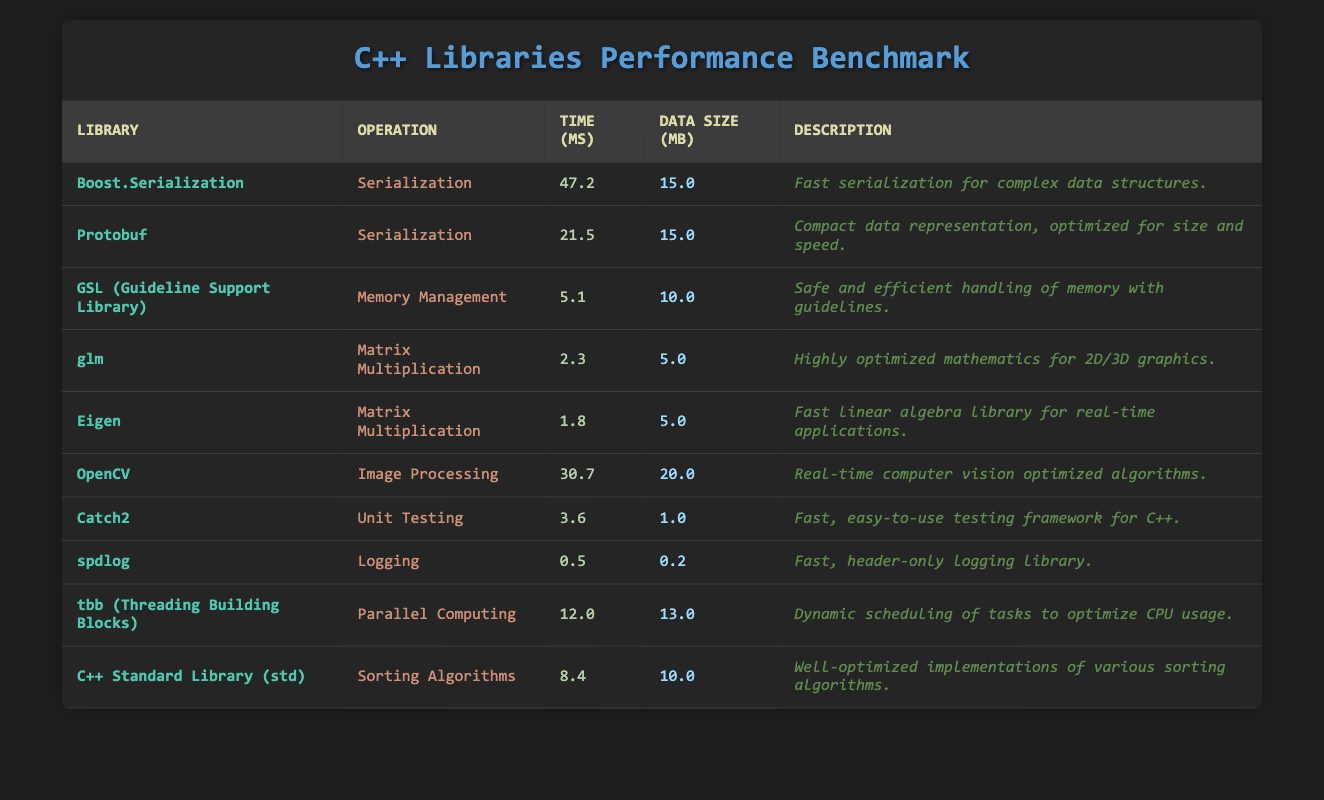What library took the longest time for serialization? The table shows that Boost.Serialization took the longest time for serialization at 47.2 ms, compared to Protobuf at 21.5 ms.
Answer: Boost.Serialization Which library is the fastest for matrix multiplication? According to the table, Eigen took 1.8 ms for matrix multiplication, making it the fastest compared to glm, which took 2.3 ms.
Answer: Eigen What is the average time taken for sorting algorithms in C++ Standard Library? The C++ Standard Library's sorting algorithm took 8.4 ms, and since there is only one entry for sorting algorithms, the average time remains 8.4 ms.
Answer: 8.4 ms Is spdlog faster than GSL for memory management? The table shows that spdlog took 0.5 ms for logging, while GSL took 5.1 ms for memory management, indicating that spdlog is faster.
Answer: Yes What is the total time taken for image processing and parallel computing operations? The time taken for image processing using OpenCV is 30.7 ms, and for parallel computing using tbb, it is 12.0 ms. Adding these gives 30.7 + 12.0 = 42.7 ms for both operations.
Answer: 42.7 ms Which operation is associated with the GSL library? The GSL library is associated with memory management according to the table provided.
Answer: Memory Management What is the difference in time between the fastest and slowest library operations in the table? The fastest operation is spdlog at 0.5 ms and the slowest is Boost.Serialization at 47.2 ms. The difference is 47.2 - 0.5 = 46.7 ms.
Answer: 46.7 ms Is the data size used in OpenCV greater than that in glm? The table shows that OpenCV uses 20.0 MB while glm uses 5.0 MB, confirming that OpenCV's data size is greater.
Answer: Yes What is the average time taken for all operations in the table? The total time taken for all operations is 47.2 + 21.5 + 5.1 + 2.3 + 1.8 + 30.7 + 3.6 + 0.5 + 12.0 + 8.4 = 132.7 ms. There are 10 operations, so the average is 132.7 / 10 = 13.27 ms.
Answer: 13.27 ms Which library specializes in logging, and how much time does it take? The library that specializes in logging is spdlog, which takes 0.5 ms for the logging operation.
Answer: spdlog, 0.5 ms 